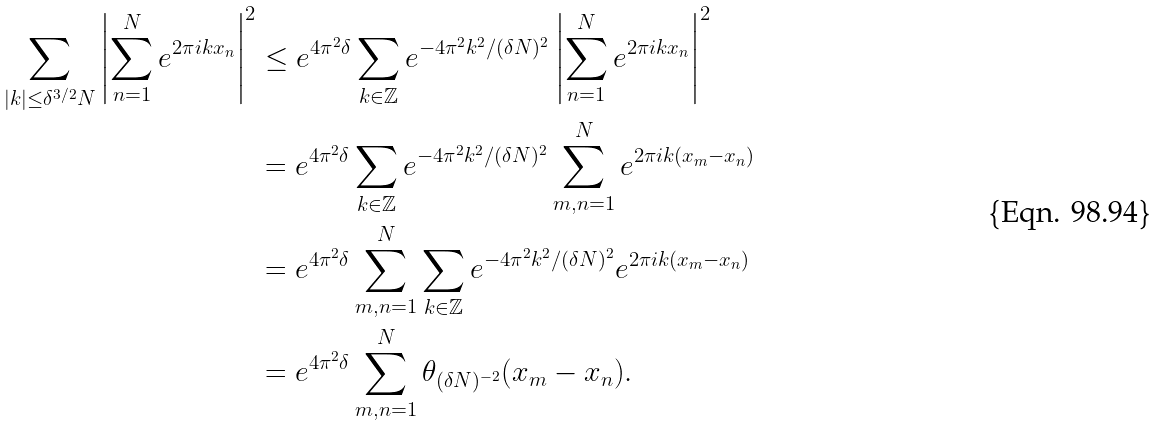Convert formula to latex. <formula><loc_0><loc_0><loc_500><loc_500>\sum _ { | k | \leq \delta ^ { 3 / 2 } N } { \left | \sum _ { n = 1 } ^ { N } { e ^ { 2 \pi i k x _ { n } } } \right | ^ { 2 } } & \leq e ^ { 4 \pi ^ { 2 } \delta } \sum _ { k \in \mathbb { Z } } { e ^ { - 4 \pi ^ { 2 } k ^ { 2 } / ( \delta N ) ^ { 2 } } \left | \sum _ { n = 1 } ^ { N } { e ^ { 2 \pi i k x _ { n } } } \right | ^ { 2 } } \\ & = e ^ { 4 \pi ^ { 2 } \delta } \sum _ { k \in \mathbb { Z } } { e ^ { - 4 \pi ^ { 2 } k ^ { 2 } / ( \delta N ) ^ { 2 } } \sum _ { m , n = 1 } ^ { N } { e ^ { 2 \pi i k ( x _ { m } - x _ { n } ) } } } \\ & = e ^ { 4 \pi ^ { 2 } \delta } \sum _ { m , n = 1 } ^ { N } \sum _ { k \in \mathbb { Z } } { e ^ { - 4 \pi ^ { 2 } k ^ { 2 } / ( \delta N ) ^ { 2 } } e ^ { 2 \pi i k ( x _ { m } - x _ { n } ) } } \\ & = e ^ { 4 \pi ^ { 2 } \delta } \sum _ { m , n = 1 } ^ { N } { \theta _ { ( \delta N ) ^ { - 2 } } ( x _ { m } - x _ { n } ) } .</formula> 